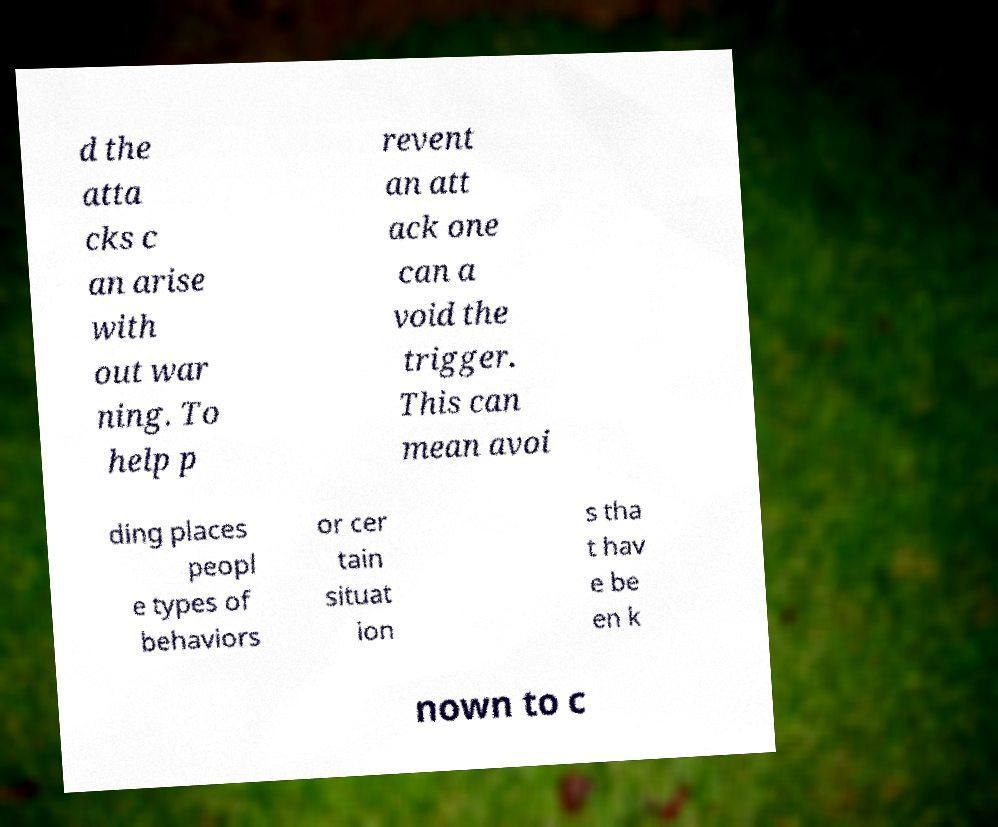Please read and relay the text visible in this image. What does it say? d the atta cks c an arise with out war ning. To help p revent an att ack one can a void the trigger. This can mean avoi ding places peopl e types of behaviors or cer tain situat ion s tha t hav e be en k nown to c 